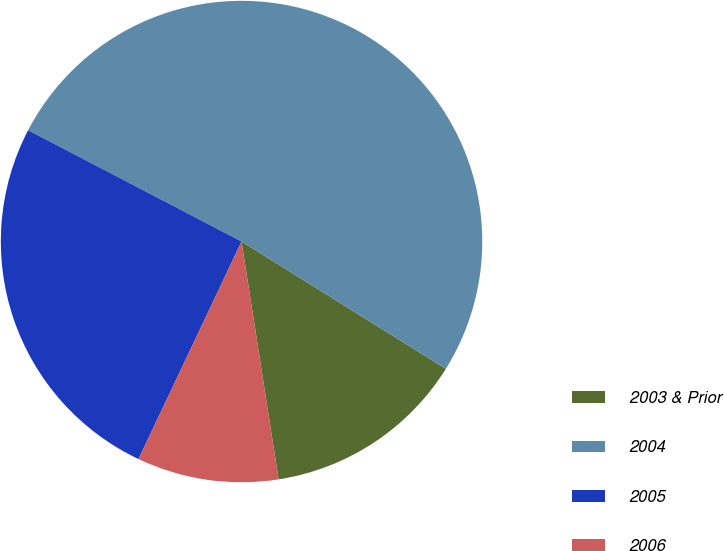Convert chart to OTSL. <chart><loc_0><loc_0><loc_500><loc_500><pie_chart><fcel>2003 & Prior<fcel>2004<fcel>2005<fcel>2006<nl><fcel>13.67%<fcel>51.22%<fcel>25.61%<fcel>9.5%<nl></chart> 